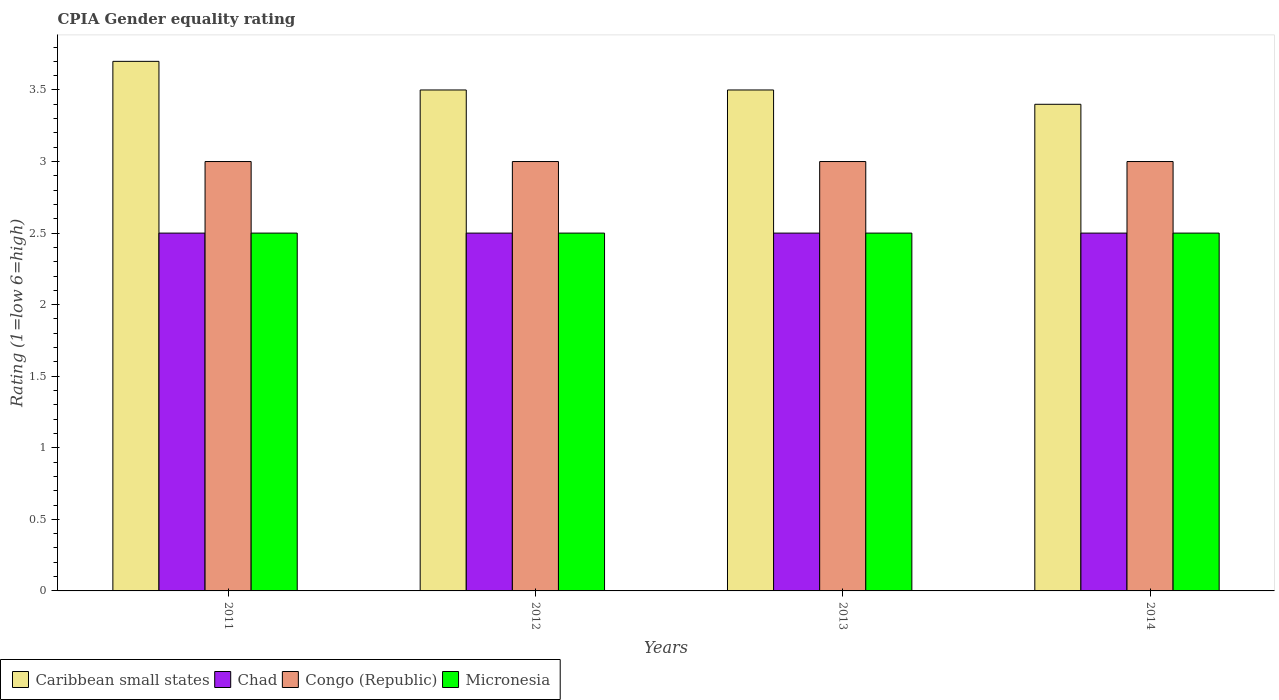Are the number of bars per tick equal to the number of legend labels?
Offer a terse response. Yes. Are the number of bars on each tick of the X-axis equal?
Offer a terse response. Yes. In how many cases, is the number of bars for a given year not equal to the number of legend labels?
Your answer should be very brief. 0. Across all years, what is the maximum CPIA rating in Congo (Republic)?
Make the answer very short. 3. What is the total CPIA rating in Chad in the graph?
Keep it short and to the point. 10. What is the difference between the CPIA rating in Chad in 2012 and that in 2013?
Provide a short and direct response. 0. What is the difference between the CPIA rating in Micronesia in 2011 and the CPIA rating in Congo (Republic) in 2013?
Provide a short and direct response. -0.5. What is the average CPIA rating in Chad per year?
Your answer should be compact. 2.5. In the year 2014, what is the difference between the CPIA rating in Caribbean small states and CPIA rating in Congo (Republic)?
Keep it short and to the point. 0.4. In how many years, is the CPIA rating in Chad greater than 0.7?
Provide a short and direct response. 4. What is the ratio of the CPIA rating in Congo (Republic) in 2012 to that in 2013?
Provide a short and direct response. 1. What is the difference between the highest and the second highest CPIA rating in Caribbean small states?
Your answer should be very brief. 0.2. What is the difference between the highest and the lowest CPIA rating in Chad?
Offer a very short reply. 0. Is it the case that in every year, the sum of the CPIA rating in Caribbean small states and CPIA rating in Congo (Republic) is greater than the sum of CPIA rating in Chad and CPIA rating in Micronesia?
Your answer should be very brief. Yes. What does the 3rd bar from the left in 2014 represents?
Ensure brevity in your answer.  Congo (Republic). What does the 2nd bar from the right in 2014 represents?
Your answer should be compact. Congo (Republic). Is it the case that in every year, the sum of the CPIA rating in Micronesia and CPIA rating in Caribbean small states is greater than the CPIA rating in Chad?
Ensure brevity in your answer.  Yes. Are all the bars in the graph horizontal?
Provide a succinct answer. No. How many years are there in the graph?
Your answer should be compact. 4. What is the difference between two consecutive major ticks on the Y-axis?
Give a very brief answer. 0.5. Are the values on the major ticks of Y-axis written in scientific E-notation?
Your answer should be very brief. No. Where does the legend appear in the graph?
Provide a succinct answer. Bottom left. How many legend labels are there?
Keep it short and to the point. 4. How are the legend labels stacked?
Your answer should be very brief. Horizontal. What is the title of the graph?
Provide a succinct answer. CPIA Gender equality rating. Does "Grenada" appear as one of the legend labels in the graph?
Offer a terse response. No. What is the label or title of the X-axis?
Provide a short and direct response. Years. What is the label or title of the Y-axis?
Give a very brief answer. Rating (1=low 6=high). What is the Rating (1=low 6=high) in Chad in 2011?
Make the answer very short. 2.5. What is the Rating (1=low 6=high) of Congo (Republic) in 2011?
Make the answer very short. 3. What is the Rating (1=low 6=high) of Caribbean small states in 2012?
Make the answer very short. 3.5. What is the Rating (1=low 6=high) of Congo (Republic) in 2012?
Your answer should be very brief. 3. What is the Rating (1=low 6=high) in Congo (Republic) in 2013?
Make the answer very short. 3. What is the Rating (1=low 6=high) in Micronesia in 2013?
Offer a very short reply. 2.5. What is the Rating (1=low 6=high) in Congo (Republic) in 2014?
Provide a short and direct response. 3. Across all years, what is the maximum Rating (1=low 6=high) in Caribbean small states?
Give a very brief answer. 3.7. Across all years, what is the maximum Rating (1=low 6=high) in Chad?
Your answer should be compact. 2.5. Across all years, what is the maximum Rating (1=low 6=high) of Micronesia?
Make the answer very short. 2.5. Across all years, what is the minimum Rating (1=low 6=high) in Chad?
Your answer should be compact. 2.5. Across all years, what is the minimum Rating (1=low 6=high) of Congo (Republic)?
Keep it short and to the point. 3. Across all years, what is the minimum Rating (1=low 6=high) in Micronesia?
Your answer should be compact. 2.5. What is the total Rating (1=low 6=high) of Micronesia in the graph?
Provide a succinct answer. 10. What is the difference between the Rating (1=low 6=high) in Caribbean small states in 2011 and that in 2013?
Provide a succinct answer. 0.2. What is the difference between the Rating (1=low 6=high) of Congo (Republic) in 2011 and that in 2013?
Offer a terse response. 0. What is the difference between the Rating (1=low 6=high) in Micronesia in 2011 and that in 2013?
Make the answer very short. 0. What is the difference between the Rating (1=low 6=high) of Micronesia in 2011 and that in 2014?
Keep it short and to the point. 0. What is the difference between the Rating (1=low 6=high) of Caribbean small states in 2012 and that in 2013?
Give a very brief answer. 0. What is the difference between the Rating (1=low 6=high) of Chad in 2012 and that in 2013?
Ensure brevity in your answer.  0. What is the difference between the Rating (1=low 6=high) in Caribbean small states in 2012 and that in 2014?
Offer a terse response. 0.1. What is the difference between the Rating (1=low 6=high) of Chad in 2012 and that in 2014?
Make the answer very short. 0. What is the difference between the Rating (1=low 6=high) of Congo (Republic) in 2012 and that in 2014?
Offer a terse response. 0. What is the difference between the Rating (1=low 6=high) of Caribbean small states in 2013 and that in 2014?
Offer a very short reply. 0.1. What is the difference between the Rating (1=low 6=high) of Chad in 2013 and that in 2014?
Offer a very short reply. 0. What is the difference between the Rating (1=low 6=high) in Congo (Republic) in 2013 and that in 2014?
Provide a short and direct response. 0. What is the difference between the Rating (1=low 6=high) of Caribbean small states in 2011 and the Rating (1=low 6=high) of Chad in 2013?
Provide a succinct answer. 1.2. What is the difference between the Rating (1=low 6=high) in Caribbean small states in 2011 and the Rating (1=low 6=high) in Congo (Republic) in 2013?
Your answer should be very brief. 0.7. What is the difference between the Rating (1=low 6=high) in Caribbean small states in 2011 and the Rating (1=low 6=high) in Micronesia in 2013?
Your response must be concise. 1.2. What is the difference between the Rating (1=low 6=high) of Chad in 2011 and the Rating (1=low 6=high) of Micronesia in 2013?
Your response must be concise. 0. What is the difference between the Rating (1=low 6=high) in Chad in 2011 and the Rating (1=low 6=high) in Congo (Republic) in 2014?
Provide a short and direct response. -0.5. What is the difference between the Rating (1=low 6=high) in Chad in 2011 and the Rating (1=low 6=high) in Micronesia in 2014?
Offer a very short reply. 0. What is the difference between the Rating (1=low 6=high) of Congo (Republic) in 2011 and the Rating (1=low 6=high) of Micronesia in 2014?
Your answer should be very brief. 0.5. What is the difference between the Rating (1=low 6=high) of Caribbean small states in 2012 and the Rating (1=low 6=high) of Chad in 2013?
Give a very brief answer. 1. What is the difference between the Rating (1=low 6=high) in Caribbean small states in 2012 and the Rating (1=low 6=high) in Congo (Republic) in 2013?
Offer a very short reply. 0.5. What is the difference between the Rating (1=low 6=high) of Chad in 2012 and the Rating (1=low 6=high) of Congo (Republic) in 2013?
Your response must be concise. -0.5. What is the difference between the Rating (1=low 6=high) of Caribbean small states in 2012 and the Rating (1=low 6=high) of Congo (Republic) in 2014?
Provide a succinct answer. 0.5. What is the difference between the Rating (1=low 6=high) in Caribbean small states in 2012 and the Rating (1=low 6=high) in Micronesia in 2014?
Ensure brevity in your answer.  1. What is the difference between the Rating (1=low 6=high) of Congo (Republic) in 2012 and the Rating (1=low 6=high) of Micronesia in 2014?
Offer a very short reply. 0.5. What is the difference between the Rating (1=low 6=high) in Caribbean small states in 2013 and the Rating (1=low 6=high) in Chad in 2014?
Your answer should be compact. 1. What is the difference between the Rating (1=low 6=high) in Caribbean small states in 2013 and the Rating (1=low 6=high) in Congo (Republic) in 2014?
Make the answer very short. 0.5. What is the average Rating (1=low 6=high) in Caribbean small states per year?
Offer a terse response. 3.52. What is the average Rating (1=low 6=high) of Micronesia per year?
Your answer should be very brief. 2.5. In the year 2011, what is the difference between the Rating (1=low 6=high) in Caribbean small states and Rating (1=low 6=high) in Congo (Republic)?
Your response must be concise. 0.7. In the year 2011, what is the difference between the Rating (1=low 6=high) in Chad and Rating (1=low 6=high) in Micronesia?
Offer a very short reply. 0. In the year 2011, what is the difference between the Rating (1=low 6=high) of Congo (Republic) and Rating (1=low 6=high) of Micronesia?
Provide a succinct answer. 0.5. In the year 2012, what is the difference between the Rating (1=low 6=high) in Caribbean small states and Rating (1=low 6=high) in Congo (Republic)?
Provide a short and direct response. 0.5. In the year 2012, what is the difference between the Rating (1=low 6=high) in Chad and Rating (1=low 6=high) in Micronesia?
Your response must be concise. 0. In the year 2013, what is the difference between the Rating (1=low 6=high) of Caribbean small states and Rating (1=low 6=high) of Chad?
Ensure brevity in your answer.  1. In the year 2013, what is the difference between the Rating (1=low 6=high) in Caribbean small states and Rating (1=low 6=high) in Congo (Republic)?
Provide a short and direct response. 0.5. In the year 2013, what is the difference between the Rating (1=low 6=high) in Caribbean small states and Rating (1=low 6=high) in Micronesia?
Your answer should be very brief. 1. In the year 2013, what is the difference between the Rating (1=low 6=high) of Chad and Rating (1=low 6=high) of Congo (Republic)?
Offer a terse response. -0.5. In the year 2013, what is the difference between the Rating (1=low 6=high) in Congo (Republic) and Rating (1=low 6=high) in Micronesia?
Your answer should be compact. 0.5. In the year 2014, what is the difference between the Rating (1=low 6=high) of Caribbean small states and Rating (1=low 6=high) of Chad?
Your answer should be compact. 0.9. In the year 2014, what is the difference between the Rating (1=low 6=high) of Caribbean small states and Rating (1=low 6=high) of Micronesia?
Your answer should be compact. 0.9. What is the ratio of the Rating (1=low 6=high) of Caribbean small states in 2011 to that in 2012?
Your answer should be very brief. 1.06. What is the ratio of the Rating (1=low 6=high) of Caribbean small states in 2011 to that in 2013?
Give a very brief answer. 1.06. What is the ratio of the Rating (1=low 6=high) of Chad in 2011 to that in 2013?
Your answer should be very brief. 1. What is the ratio of the Rating (1=low 6=high) in Congo (Republic) in 2011 to that in 2013?
Your answer should be very brief. 1. What is the ratio of the Rating (1=low 6=high) of Caribbean small states in 2011 to that in 2014?
Ensure brevity in your answer.  1.09. What is the ratio of the Rating (1=low 6=high) in Congo (Republic) in 2011 to that in 2014?
Keep it short and to the point. 1. What is the ratio of the Rating (1=low 6=high) of Micronesia in 2012 to that in 2013?
Provide a succinct answer. 1. What is the ratio of the Rating (1=low 6=high) in Caribbean small states in 2012 to that in 2014?
Your answer should be compact. 1.03. What is the ratio of the Rating (1=low 6=high) of Micronesia in 2012 to that in 2014?
Ensure brevity in your answer.  1. What is the ratio of the Rating (1=low 6=high) in Caribbean small states in 2013 to that in 2014?
Your answer should be compact. 1.03. What is the ratio of the Rating (1=low 6=high) of Congo (Republic) in 2013 to that in 2014?
Provide a succinct answer. 1. What is the ratio of the Rating (1=low 6=high) in Micronesia in 2013 to that in 2014?
Your response must be concise. 1. What is the difference between the highest and the second highest Rating (1=low 6=high) in Caribbean small states?
Offer a terse response. 0.2. What is the difference between the highest and the second highest Rating (1=low 6=high) in Micronesia?
Your response must be concise. 0. What is the difference between the highest and the lowest Rating (1=low 6=high) of Caribbean small states?
Ensure brevity in your answer.  0.3. What is the difference between the highest and the lowest Rating (1=low 6=high) of Micronesia?
Your answer should be compact. 0. 